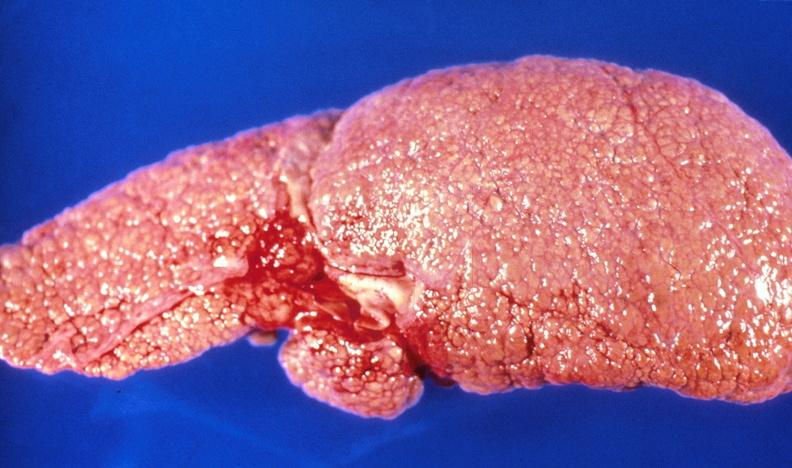s liver present?
Answer the question using a single word or phrase. Yes 